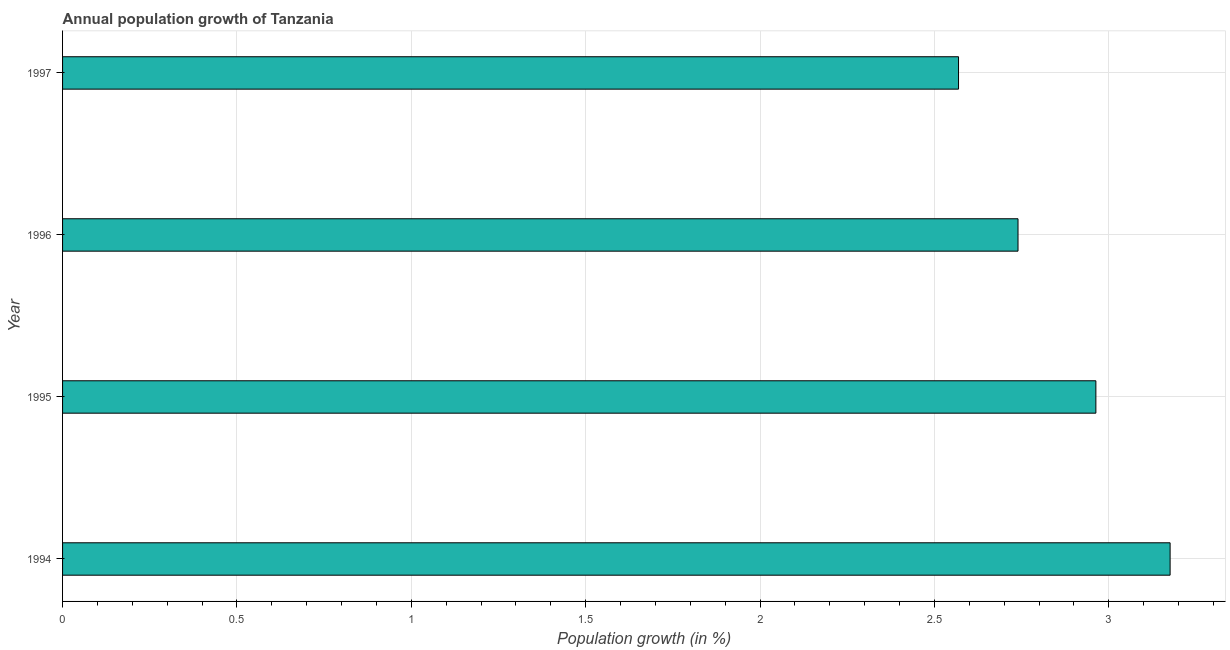Does the graph contain any zero values?
Your answer should be compact. No. What is the title of the graph?
Offer a terse response. Annual population growth of Tanzania. What is the label or title of the X-axis?
Ensure brevity in your answer.  Population growth (in %). What is the label or title of the Y-axis?
Your answer should be compact. Year. What is the population growth in 1995?
Keep it short and to the point. 2.96. Across all years, what is the maximum population growth?
Offer a very short reply. 3.18. Across all years, what is the minimum population growth?
Offer a very short reply. 2.57. In which year was the population growth maximum?
Offer a terse response. 1994. In which year was the population growth minimum?
Offer a terse response. 1997. What is the sum of the population growth?
Provide a succinct answer. 11.45. What is the difference between the population growth in 1994 and 1997?
Provide a succinct answer. 0.61. What is the average population growth per year?
Your answer should be very brief. 2.86. What is the median population growth?
Provide a short and direct response. 2.85. Do a majority of the years between 1994 and 1996 (inclusive) have population growth greater than 1.4 %?
Your answer should be very brief. Yes. What is the ratio of the population growth in 1996 to that in 1997?
Offer a very short reply. 1.07. What is the difference between the highest and the second highest population growth?
Your answer should be very brief. 0.21. Is the sum of the population growth in 1995 and 1997 greater than the maximum population growth across all years?
Offer a very short reply. Yes. What is the difference between the highest and the lowest population growth?
Your answer should be compact. 0.61. In how many years, is the population growth greater than the average population growth taken over all years?
Your response must be concise. 2. How many bars are there?
Provide a short and direct response. 4. How many years are there in the graph?
Ensure brevity in your answer.  4. What is the difference between two consecutive major ticks on the X-axis?
Give a very brief answer. 0.5. What is the Population growth (in %) in 1994?
Provide a short and direct response. 3.18. What is the Population growth (in %) in 1995?
Your answer should be very brief. 2.96. What is the Population growth (in %) in 1996?
Your answer should be very brief. 2.74. What is the Population growth (in %) of 1997?
Your answer should be very brief. 2.57. What is the difference between the Population growth (in %) in 1994 and 1995?
Give a very brief answer. 0.21. What is the difference between the Population growth (in %) in 1994 and 1996?
Provide a succinct answer. 0.44. What is the difference between the Population growth (in %) in 1994 and 1997?
Keep it short and to the point. 0.61. What is the difference between the Population growth (in %) in 1995 and 1996?
Offer a terse response. 0.22. What is the difference between the Population growth (in %) in 1995 and 1997?
Keep it short and to the point. 0.39. What is the difference between the Population growth (in %) in 1996 and 1997?
Keep it short and to the point. 0.17. What is the ratio of the Population growth (in %) in 1994 to that in 1995?
Offer a terse response. 1.07. What is the ratio of the Population growth (in %) in 1994 to that in 1996?
Your response must be concise. 1.16. What is the ratio of the Population growth (in %) in 1994 to that in 1997?
Offer a terse response. 1.24. What is the ratio of the Population growth (in %) in 1995 to that in 1996?
Make the answer very short. 1.08. What is the ratio of the Population growth (in %) in 1995 to that in 1997?
Provide a succinct answer. 1.15. What is the ratio of the Population growth (in %) in 1996 to that in 1997?
Your response must be concise. 1.07. 